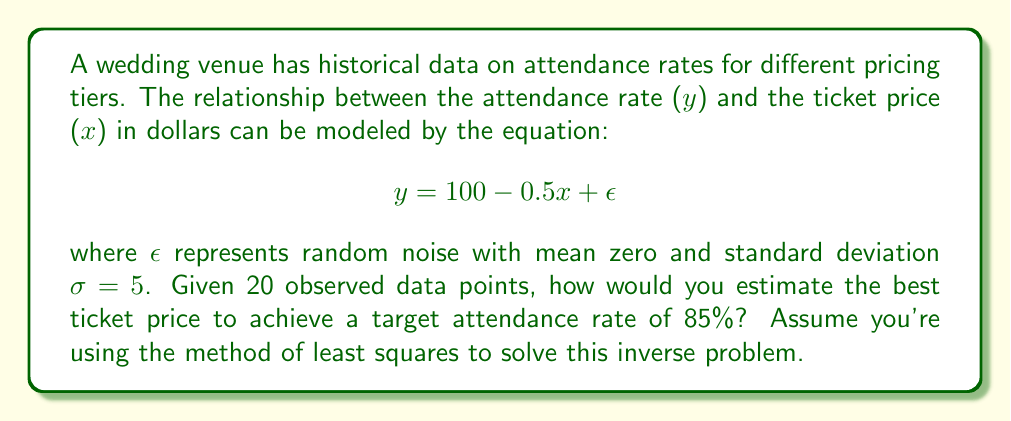Show me your answer to this math problem. To solve this inverse problem using the method of least squares:

1) First, we need to find the best-fit line for the data points. The general form of the line is:
   $$y = a + bx$$
   where $a = 100$ and $b = -0.5$ based on the given equation.

2) To achieve the target attendance rate of 85%, we set $y = 85$ in our equation:
   $$85 = 100 - 0.5x$$

3) Solve for $x$:
   $$-0.5x = -15$$
   $$x = 30$$

4) However, this is just the point estimate. To account for the uncertainty due to noise, we need to calculate the confidence interval.

5) The standard error of the estimate (SEE) is given by:
   $$SEE = \frac{\sigma}{\sqrt{n}} = \frac{5}{\sqrt{20}} = 1.12$$

6) For a 95% confidence interval, we use 1.96 * SEE:
   $$1.96 * 1.12 = 2.19$$

7) Therefore, the 95% confidence interval for the ticket price is:
   $$30 \pm 2.19$$
   or $[27.81, 32.19]$

8) As an event coordinator, you might want to choose a price at the lower end of this interval to ensure meeting the attendance target.
Answer: $30 \pm 2.19$ (or more precisely, [27.81, 32.19]) 